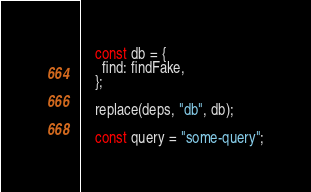Convert code to text. <code><loc_0><loc_0><loc_500><loc_500><_JavaScript_>
    const db = {
      find: findFake,
    };

    replace(deps, "db", db);

    const query = "some-query";</code> 